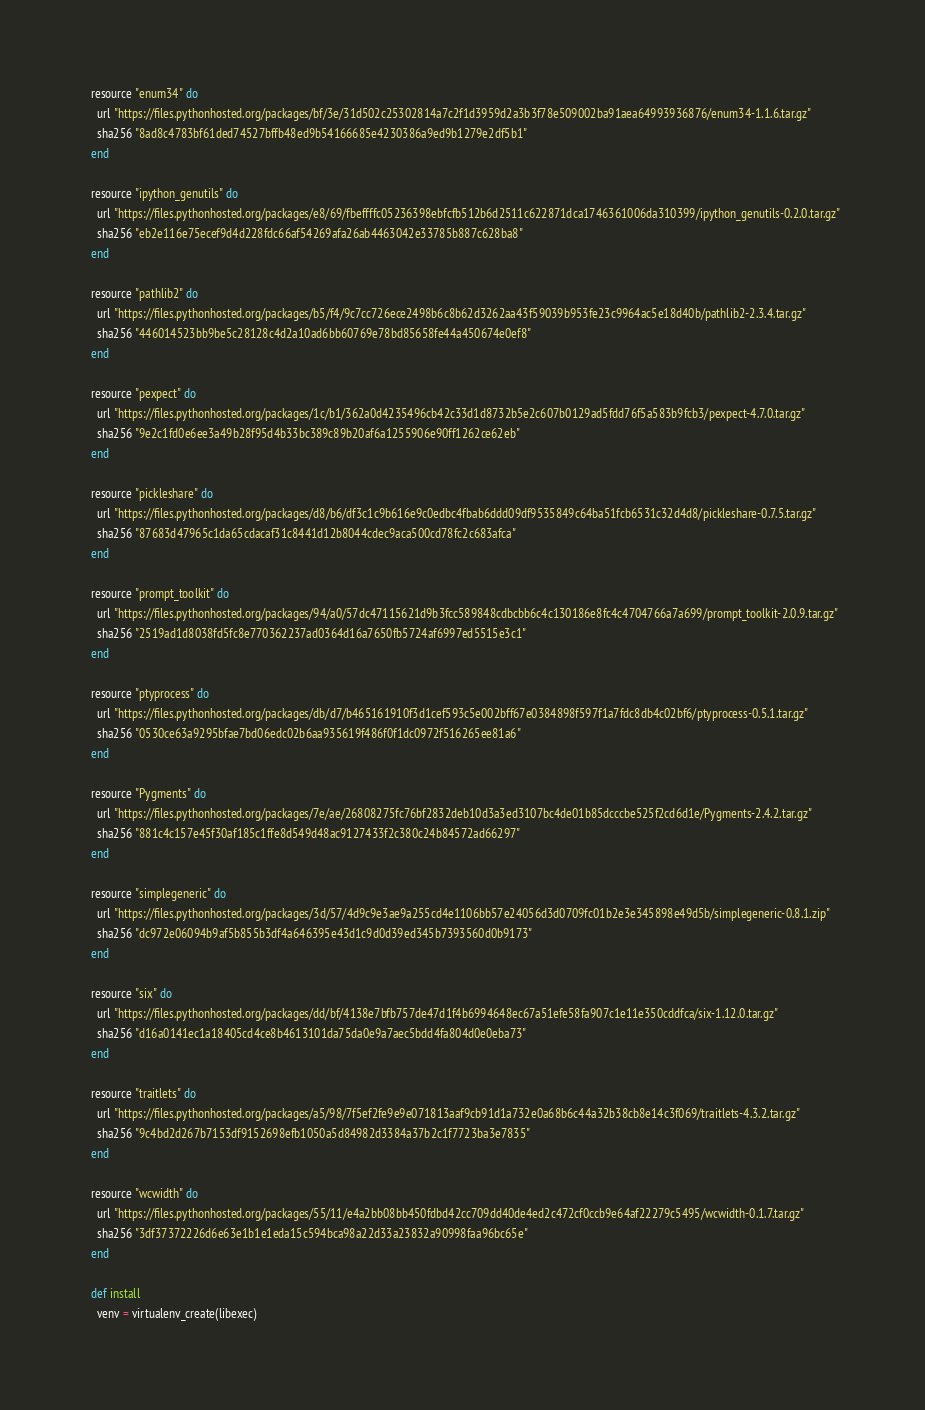Convert code to text. <code><loc_0><loc_0><loc_500><loc_500><_Ruby_>  resource "enum34" do
    url "https://files.pythonhosted.org/packages/bf/3e/31d502c25302814a7c2f1d3959d2a3b3f78e509002ba91aea64993936876/enum34-1.1.6.tar.gz"
    sha256 "8ad8c4783bf61ded74527bffb48ed9b54166685e4230386a9ed9b1279e2df5b1"
  end

  resource "ipython_genutils" do
    url "https://files.pythonhosted.org/packages/e8/69/fbeffffc05236398ebfcfb512b6d2511c622871dca1746361006da310399/ipython_genutils-0.2.0.tar.gz"
    sha256 "eb2e116e75ecef9d4d228fdc66af54269afa26ab4463042e33785b887c628ba8"
  end

  resource "pathlib2" do
    url "https://files.pythonhosted.org/packages/b5/f4/9c7cc726ece2498b6c8b62d3262aa43f59039b953fe23c9964ac5e18d40b/pathlib2-2.3.4.tar.gz"
    sha256 "446014523bb9be5c28128c4d2a10ad6bb60769e78bd85658fe44a450674e0ef8"
  end

  resource "pexpect" do
    url "https://files.pythonhosted.org/packages/1c/b1/362a0d4235496cb42c33d1d8732b5e2c607b0129ad5fdd76f5a583b9fcb3/pexpect-4.7.0.tar.gz"
    sha256 "9e2c1fd0e6ee3a49b28f95d4b33bc389c89b20af6a1255906e90ff1262ce62eb"
  end

  resource "pickleshare" do
    url "https://files.pythonhosted.org/packages/d8/b6/df3c1c9b616e9c0edbc4fbab6ddd09df9535849c64ba51fcb6531c32d4d8/pickleshare-0.7.5.tar.gz"
    sha256 "87683d47965c1da65cdacaf31c8441d12b8044cdec9aca500cd78fc2c683afca"
  end

  resource "prompt_toolkit" do
    url "https://files.pythonhosted.org/packages/94/a0/57dc47115621d9b3fcc589848cdbcbb6c4c130186e8fc4c4704766a7a699/prompt_toolkit-2.0.9.tar.gz"
    sha256 "2519ad1d8038fd5fc8e770362237ad0364d16a7650fb5724af6997ed5515e3c1"
  end

  resource "ptyprocess" do
    url "https://files.pythonhosted.org/packages/db/d7/b465161910f3d1cef593c5e002bff67e0384898f597f1a7fdc8db4c02bf6/ptyprocess-0.5.1.tar.gz"
    sha256 "0530ce63a9295bfae7bd06edc02b6aa935619f486f0f1dc0972f516265ee81a6"
  end

  resource "Pygments" do
    url "https://files.pythonhosted.org/packages/7e/ae/26808275fc76bf2832deb10d3a3ed3107bc4de01b85dcccbe525f2cd6d1e/Pygments-2.4.2.tar.gz"
    sha256 "881c4c157e45f30af185c1ffe8d549d48ac9127433f2c380c24b84572ad66297"
  end

  resource "simplegeneric" do
    url "https://files.pythonhosted.org/packages/3d/57/4d9c9e3ae9a255cd4e1106bb57e24056d3d0709fc01b2e3e345898e49d5b/simplegeneric-0.8.1.zip"
    sha256 "dc972e06094b9af5b855b3df4a646395e43d1c9d0d39ed345b7393560d0b9173"
  end

  resource "six" do
    url "https://files.pythonhosted.org/packages/dd/bf/4138e7bfb757de47d1f4b6994648ec67a51efe58fa907c1e11e350cddfca/six-1.12.0.tar.gz"
    sha256 "d16a0141ec1a18405cd4ce8b4613101da75da0e9a7aec5bdd4fa804d0e0eba73"
  end

  resource "traitlets" do
    url "https://files.pythonhosted.org/packages/a5/98/7f5ef2fe9e9e071813aaf9cb91d1a732e0a68b6c44a32b38cb8e14c3f069/traitlets-4.3.2.tar.gz"
    sha256 "9c4bd2d267b7153df9152698efb1050a5d84982d3384a37b2c1f7723ba3e7835"
  end

  resource "wcwidth" do
    url "https://files.pythonhosted.org/packages/55/11/e4a2bb08bb450fdbd42cc709dd40de4ed2c472cf0ccb9e64af22279c5495/wcwidth-0.1.7.tar.gz"
    sha256 "3df37372226d6e63e1b1e1eda15c594bca98a22d33a23832a90998faa96bc65e"
  end

  def install
    venv = virtualenv_create(libexec)
</code> 